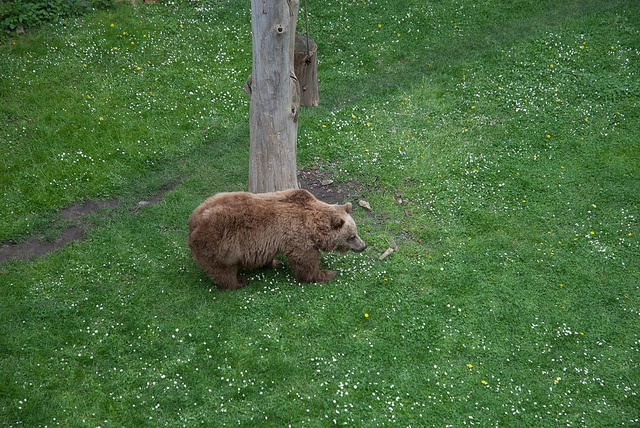Describe the objects in this image and their specific colors. I can see a bear in darkgreen, gray, black, and maroon tones in this image. 